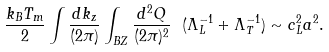<formula> <loc_0><loc_0><loc_500><loc_500>\frac { k _ { B } T _ { m } } { 2 } \int \frac { d k _ { z } } { ( 2 \pi ) } \int _ { B Z } \frac { d ^ { 2 } { Q } } { ( 2 \pi ) ^ { 2 } } \ ( \Lambda _ { L } ^ { - 1 } + \Lambda _ { T } ^ { - 1 } ) \sim c _ { L } ^ { 2 } a ^ { 2 } .</formula> 